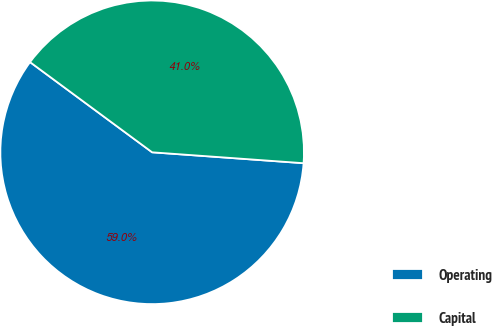<chart> <loc_0><loc_0><loc_500><loc_500><pie_chart><fcel>Operating<fcel>Capital<nl><fcel>58.98%<fcel>41.02%<nl></chart> 